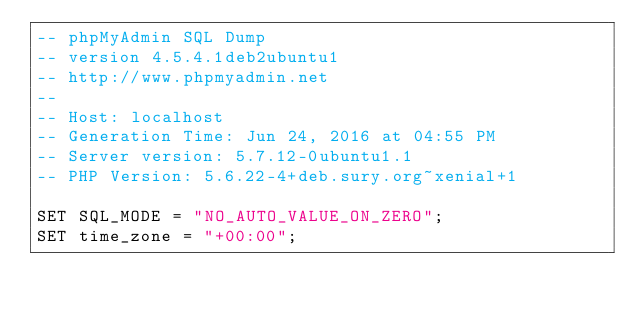<code> <loc_0><loc_0><loc_500><loc_500><_SQL_>-- phpMyAdmin SQL Dump
-- version 4.5.4.1deb2ubuntu1
-- http://www.phpmyadmin.net
--
-- Host: localhost
-- Generation Time: Jun 24, 2016 at 04:55 PM
-- Server version: 5.7.12-0ubuntu1.1
-- PHP Version: 5.6.22-4+deb.sury.org~xenial+1

SET SQL_MODE = "NO_AUTO_VALUE_ON_ZERO";
SET time_zone = "+00:00";

</code> 